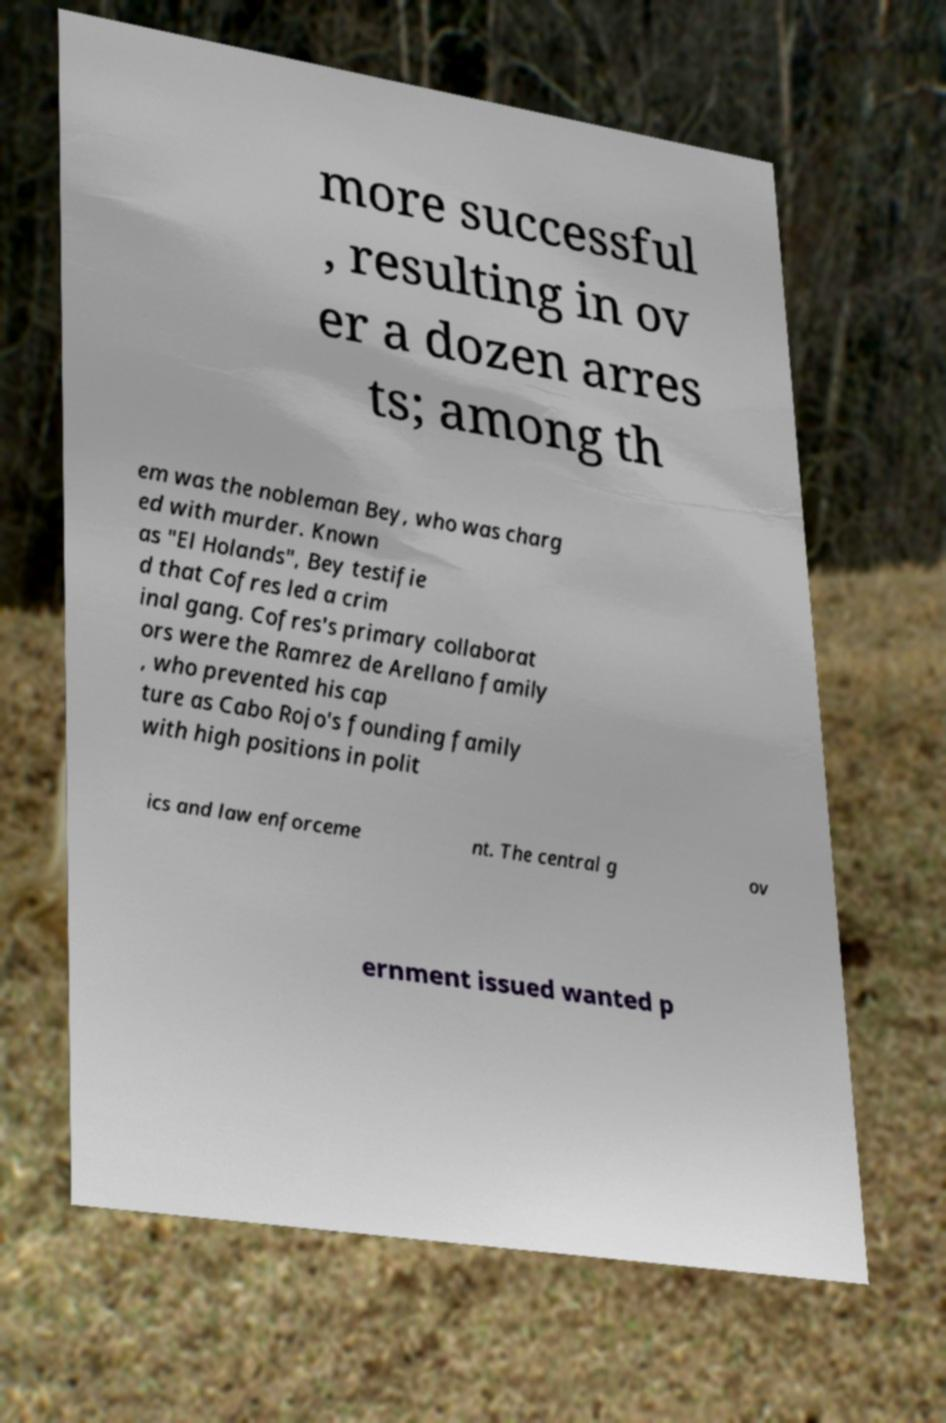Could you extract and type out the text from this image? more successful , resulting in ov er a dozen arres ts; among th em was the nobleman Bey, who was charg ed with murder. Known as "El Holands", Bey testifie d that Cofres led a crim inal gang. Cofres's primary collaborat ors were the Ramrez de Arellano family , who prevented his cap ture as Cabo Rojo's founding family with high positions in polit ics and law enforceme nt. The central g ov ernment issued wanted p 